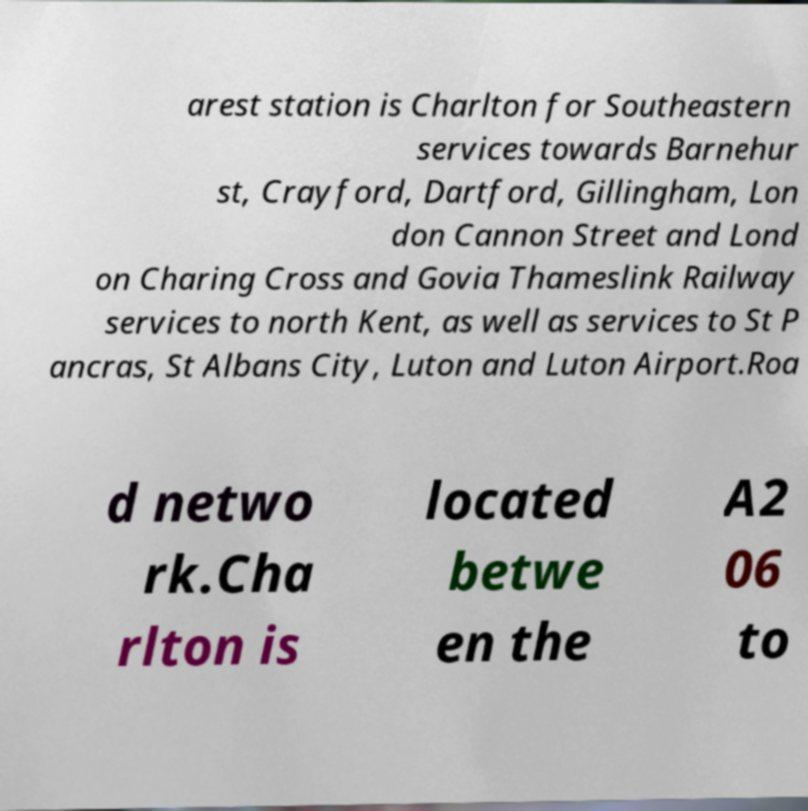Please identify and transcribe the text found in this image. arest station is Charlton for Southeastern services towards Barnehur st, Crayford, Dartford, Gillingham, Lon don Cannon Street and Lond on Charing Cross and Govia Thameslink Railway services to north Kent, as well as services to St P ancras, St Albans City, Luton and Luton Airport.Roa d netwo rk.Cha rlton is located betwe en the A2 06 to 